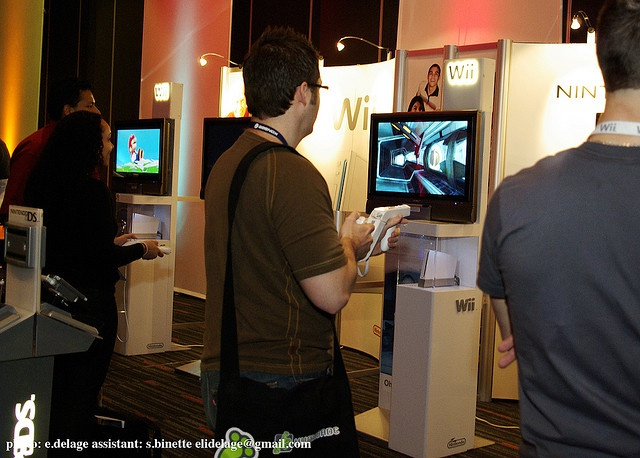Describe the objects in this image and their specific colors. I can see people in maroon, black, and gray tones, people in maroon and black tones, handbag in maroon, black, and gray tones, people in maroon, black, and brown tones, and tv in maroon, black, white, navy, and lightblue tones in this image. 